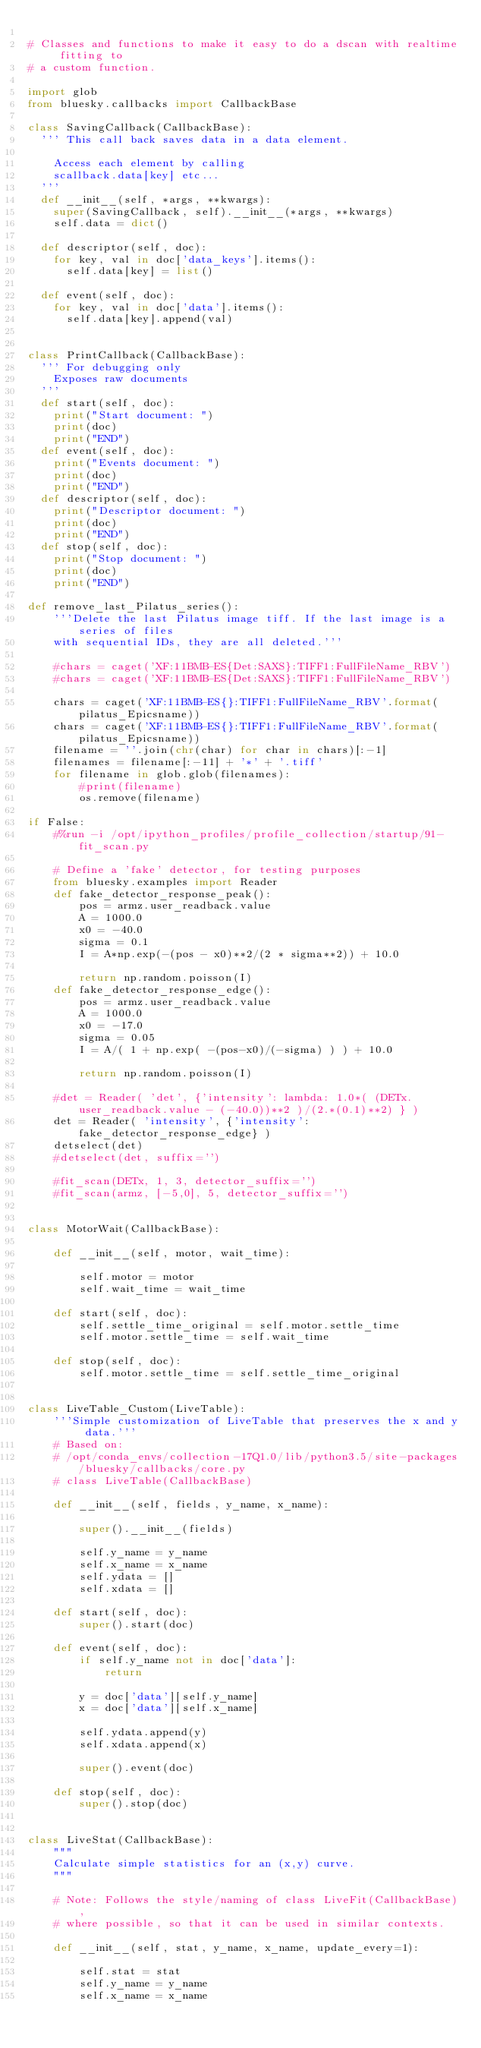Convert code to text. <code><loc_0><loc_0><loc_500><loc_500><_Python_>
# Classes and functions to make it easy to do a dscan with realtime fitting to
# a custom function.

import glob
from bluesky.callbacks import CallbackBase

class SavingCallback(CallbackBase):
	''' This call back saves data in a data element.

		Access each element by calling
		scallback.data[key] etc...
	'''
	def __init__(self, *args, **kwargs):
		super(SavingCallback, self).__init__(*args, **kwargs)
		self.data = dict()

	def descriptor(self, doc):
		for key, val in doc['data_keys'].items():
			self.data[key] = list()

	def event(self, doc):
		for key, val in doc['data'].items():
			self.data[key].append(val)


class PrintCallback(CallbackBase):
	''' For debugging only
		Exposes raw documents
	'''
	def start(self, doc):
		print("Start document: ")
		print(doc)
		print("END")
	def event(self, doc):
		print("Events document: ")
		print(doc)
		print("END")
	def descriptor(self, doc):
		print("Descriptor document: ")
		print(doc)
		print("END")
	def stop(self, doc):
		print("Stop document: ")
		print(doc)
		print("END")

def remove_last_Pilatus_series():
    '''Delete the last Pilatus image tiff. If the last image is a series of files
    with sequential IDs, they are all deleted.'''
    
    #chars = caget('XF:11BMB-ES{Det:SAXS}:TIFF1:FullFileName_RBV')
    #chars = caget('XF:11BMB-ES{Det:SAXS}:TIFF1:FullFileName_RBV')

    chars = caget('XF:11BMB-ES{}:TIFF1:FullFileName_RBV'.format(pilatus_Epicsname))
    chars = caget('XF:11BMB-ES{}:TIFF1:FullFileName_RBV'.format(pilatus_Epicsname))
    filename = ''.join(chr(char) for char in chars)[:-1]
    filenames = filename[:-11] + '*' + '.tiff'
    for filename in glob.glob(filenames):
        #print(filename)
        os.remove(filename)

if False:
    #%run -i /opt/ipython_profiles/profile_collection/startup/91-fit_scan.py
    
    # Define a 'fake' detector, for testing purposes
    from bluesky.examples import Reader
    def fake_detector_response_peak():
        pos = armz.user_readback.value
        A = 1000.0
        x0 = -40.0
        sigma = 0.1
        I = A*np.exp(-(pos - x0)**2/(2 * sigma**2)) + 10.0
        
        return np.random.poisson(I)
    def fake_detector_response_edge():
        pos = armz.user_readback.value
        A = 1000.0
        x0 = -17.0
        sigma = 0.05
        I = A/( 1 + np.exp( -(pos-x0)/(-sigma) ) ) + 10.0
        
        return np.random.poisson(I)

    #det = Reader( 'det', {'intensity': lambda: 1.0*( (DETx.user_readback.value - (-40.0))**2 )/(2.*(0.1)**2) } )    
    det = Reader( 'intensity', {'intensity': fake_detector_response_edge} )
    detselect(det)
    #detselect(det, suffix='')
    
    #fit_scan(DETx, 1, 3, detector_suffix='')
    #fit_scan(armz, [-5,0], 5, detector_suffix='')


class MotorWait(CallbackBase):
    
    def __init__(self, motor, wait_time):
        
        self.motor = motor
        self.wait_time = wait_time

    def start(self, doc):
        self.settle_time_original = self.motor.settle_time
        self.motor.settle_time = self.wait_time
    
    def stop(self, doc):
        self.motor.settle_time = self.settle_time_original


class LiveTable_Custom(LiveTable):
    '''Simple customization of LiveTable that preserves the x and y data.'''
    # Based on:
    # /opt/conda_envs/collection-17Q1.0/lib/python3.5/site-packages/bluesky/callbacks/core.py
    # class LiveTable(CallbackBase)
    
    def __init__(self, fields, y_name, x_name):
        
        super().__init__(fields)

        self.y_name = y_name
        self.x_name = x_name
        self.ydata = []
        self.xdata = []

    def start(self, doc):
        super().start(doc)

    def event(self, doc):
        if self.y_name not in doc['data']:
            return
        
        y = doc['data'][self.y_name]
        x = doc['data'][self.x_name]
        
        self.ydata.append(y)
        self.xdata.append(x)
        
        super().event(doc)

    def stop(self, doc):
        super().stop(doc)
    

class LiveStat(CallbackBase):
    """
    Calculate simple statistics for an (x,y) curve.
    """
    
    # Note: Follows the style/naming of class LiveFit(CallbackBase),
    # where possible, so that it can be used in similar contexts.
    
    def __init__(self, stat, y_name, x_name, update_every=1):
        
        self.stat = stat
        self.y_name = y_name
        self.x_name = x_name</code> 